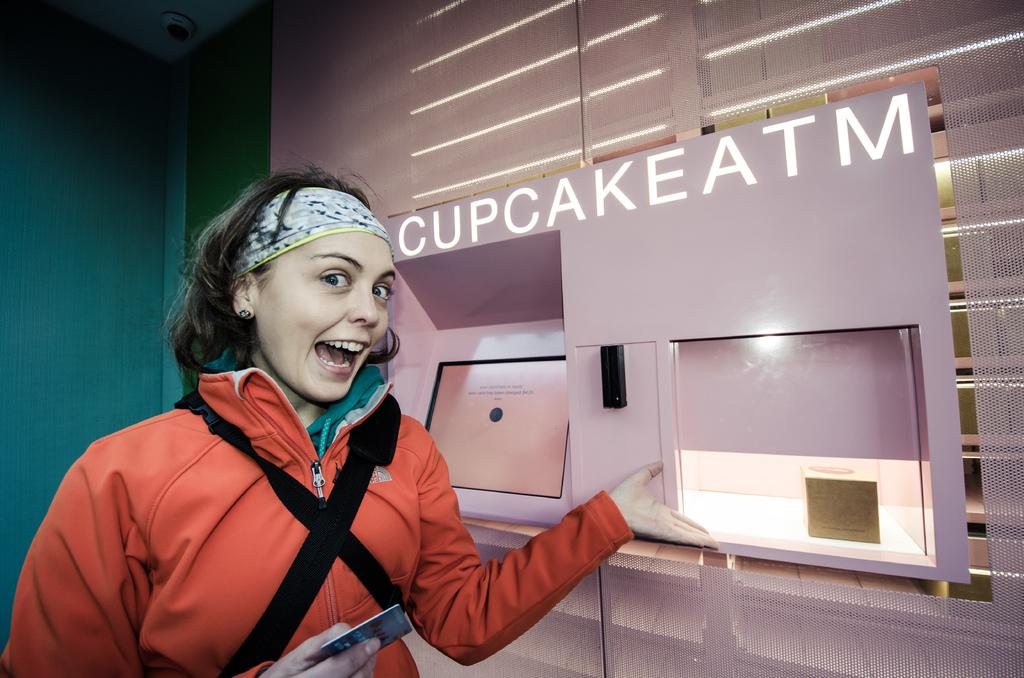Provide a one-sentence caption for the provided image. A girl showing a cupcake atm with her hand. 